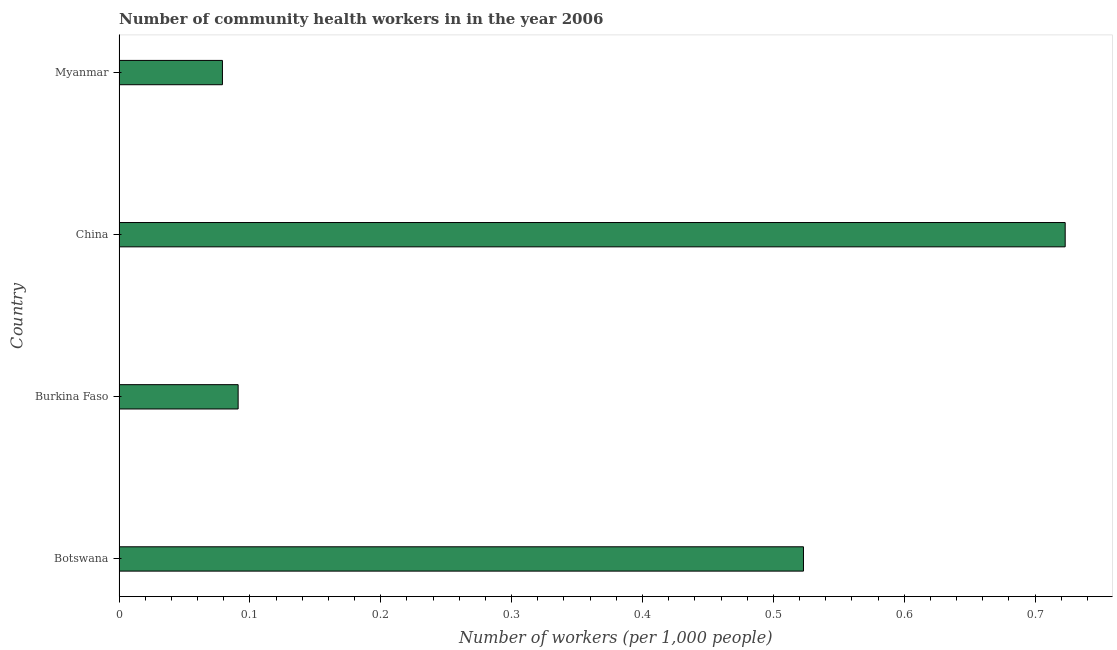Does the graph contain any zero values?
Provide a succinct answer. No. What is the title of the graph?
Make the answer very short. Number of community health workers in in the year 2006. What is the label or title of the X-axis?
Ensure brevity in your answer.  Number of workers (per 1,0 people). What is the number of community health workers in Botswana?
Give a very brief answer. 0.52. Across all countries, what is the maximum number of community health workers?
Provide a succinct answer. 0.72. Across all countries, what is the minimum number of community health workers?
Keep it short and to the point. 0.08. In which country was the number of community health workers minimum?
Your answer should be very brief. Myanmar. What is the sum of the number of community health workers?
Your answer should be very brief. 1.42. What is the difference between the number of community health workers in China and Myanmar?
Ensure brevity in your answer.  0.64. What is the average number of community health workers per country?
Make the answer very short. 0.35. What is the median number of community health workers?
Ensure brevity in your answer.  0.31. In how many countries, is the number of community health workers greater than 0.02 ?
Offer a terse response. 4. What is the ratio of the number of community health workers in Burkina Faso to that in China?
Ensure brevity in your answer.  0.13. Is the difference between the number of community health workers in Botswana and Myanmar greater than the difference between any two countries?
Your answer should be very brief. No. What is the difference between the highest and the lowest number of community health workers?
Ensure brevity in your answer.  0.64. In how many countries, is the number of community health workers greater than the average number of community health workers taken over all countries?
Your response must be concise. 2. Are all the bars in the graph horizontal?
Your response must be concise. Yes. What is the difference between two consecutive major ticks on the X-axis?
Offer a very short reply. 0.1. Are the values on the major ticks of X-axis written in scientific E-notation?
Your answer should be very brief. No. What is the Number of workers (per 1,000 people) in Botswana?
Ensure brevity in your answer.  0.52. What is the Number of workers (per 1,000 people) in Burkina Faso?
Make the answer very short. 0.09. What is the Number of workers (per 1,000 people) of China?
Offer a terse response. 0.72. What is the Number of workers (per 1,000 people) of Myanmar?
Give a very brief answer. 0.08. What is the difference between the Number of workers (per 1,000 people) in Botswana and Burkina Faso?
Keep it short and to the point. 0.43. What is the difference between the Number of workers (per 1,000 people) in Botswana and China?
Make the answer very short. -0.2. What is the difference between the Number of workers (per 1,000 people) in Botswana and Myanmar?
Your answer should be very brief. 0.44. What is the difference between the Number of workers (per 1,000 people) in Burkina Faso and China?
Make the answer very short. -0.63. What is the difference between the Number of workers (per 1,000 people) in Burkina Faso and Myanmar?
Offer a very short reply. 0.01. What is the difference between the Number of workers (per 1,000 people) in China and Myanmar?
Offer a terse response. 0.64. What is the ratio of the Number of workers (per 1,000 people) in Botswana to that in Burkina Faso?
Give a very brief answer. 5.75. What is the ratio of the Number of workers (per 1,000 people) in Botswana to that in China?
Your response must be concise. 0.72. What is the ratio of the Number of workers (per 1,000 people) in Botswana to that in Myanmar?
Provide a short and direct response. 6.62. What is the ratio of the Number of workers (per 1,000 people) in Burkina Faso to that in China?
Give a very brief answer. 0.13. What is the ratio of the Number of workers (per 1,000 people) in Burkina Faso to that in Myanmar?
Provide a succinct answer. 1.15. What is the ratio of the Number of workers (per 1,000 people) in China to that in Myanmar?
Your answer should be compact. 9.15. 